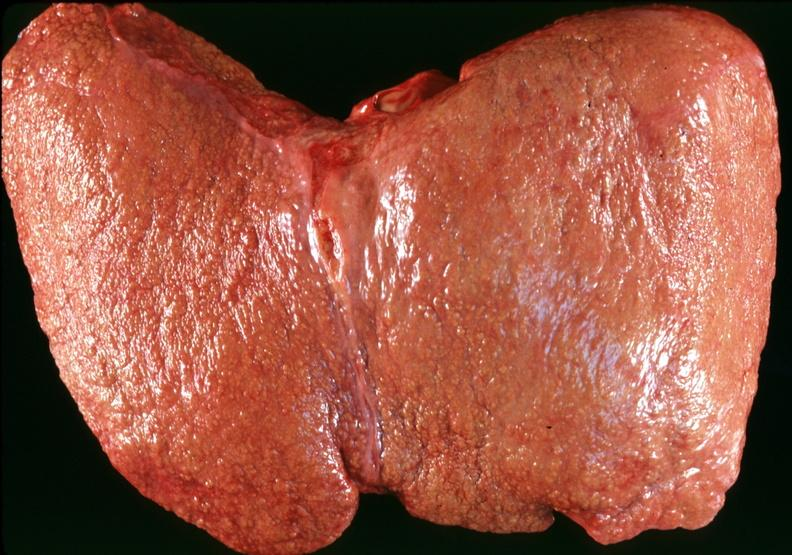s postoperative cardiac surgery present?
Answer the question using a single word or phrase. No 